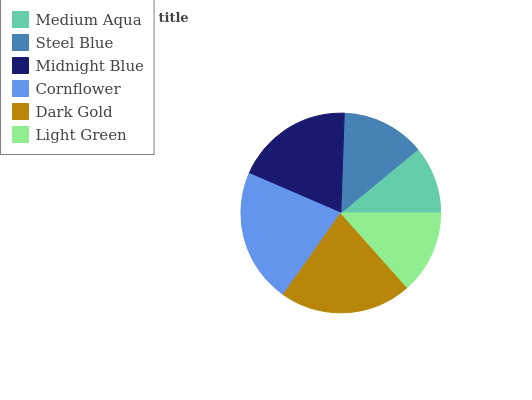Is Medium Aqua the minimum?
Answer yes or no. Yes. Is Cornflower the maximum?
Answer yes or no. Yes. Is Steel Blue the minimum?
Answer yes or no. No. Is Steel Blue the maximum?
Answer yes or no. No. Is Steel Blue greater than Medium Aqua?
Answer yes or no. Yes. Is Medium Aqua less than Steel Blue?
Answer yes or no. Yes. Is Medium Aqua greater than Steel Blue?
Answer yes or no. No. Is Steel Blue less than Medium Aqua?
Answer yes or no. No. Is Midnight Blue the high median?
Answer yes or no. Yes. Is Steel Blue the low median?
Answer yes or no. Yes. Is Dark Gold the high median?
Answer yes or no. No. Is Cornflower the low median?
Answer yes or no. No. 